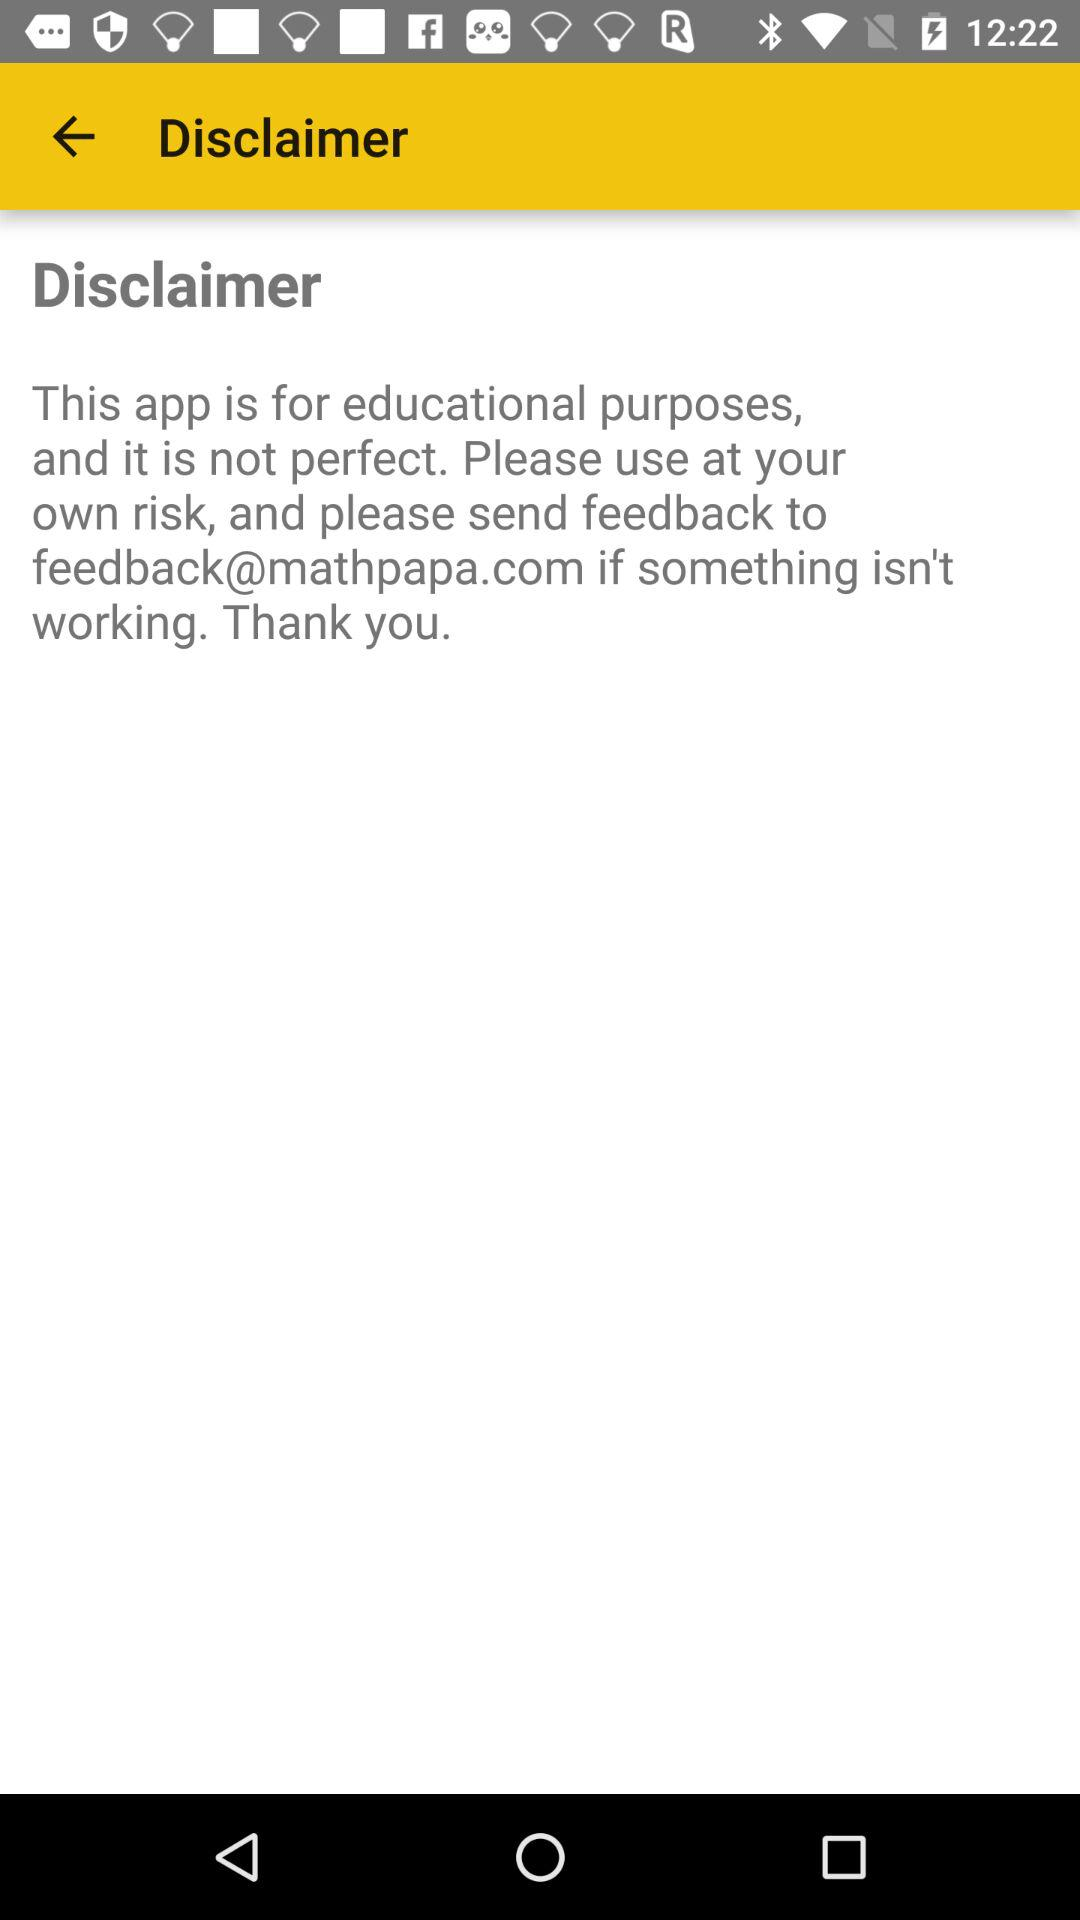What is the email address to which I can send feedback? You can send feedback at feedback@mathpapa.com. 